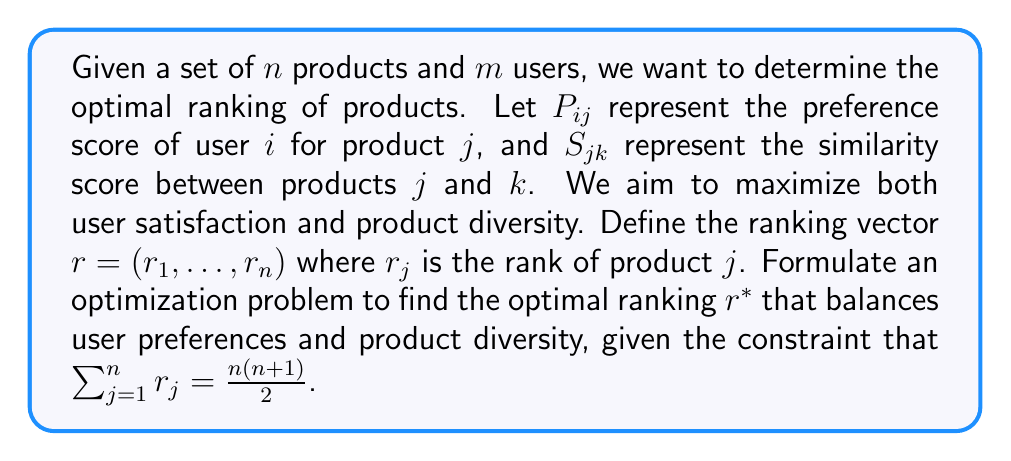Can you answer this question? To solve this inverse problem, we need to formulate an optimization problem that balances user preferences and product diversity. Let's break it down step-by-step:

1. Define the objective function:
   We want to maximize two components: user satisfaction and product diversity.

   a) User satisfaction: $\sum_{i=1}^m \sum_{j=1}^n P_{ij} \cdot (n+1-r_j)$
      This term rewards higher ranks (lower $r_j$ values) for products with higher preference scores.

   b) Product diversity: $-\lambda \sum_{j=1}^n \sum_{k=1}^n S_{jk} \cdot |r_j - r_k|$
      This term penalizes similar products having close ranks. $\lambda$ is a weighting factor.

2. Combine the components:
   $$\max_{r} \left( \sum_{i=1}^m \sum_{j=1}^n P_{ij} \cdot (n+1-r_j) - \lambda \sum_{j=1}^n \sum_{k=1}^n S_{jk} \cdot |r_j - r_k| \right)$$

3. Add the constraint:
   $$\text{subject to } \sum_{j=1}^n r_j = \frac{n(n+1)}{2}$$

4. Integer constraint:
   $$r_j \in \{1, 2, \ldots, n\} \text{ for all } j$$

5. Formulate the final optimization problem:
   $$\begin{aligned}
   \max_{r} & \left( \sum_{i=1}^m \sum_{j=1}^n P_{ij} \cdot (n+1-r_j) - \lambda \sum_{j=1}^n \sum_{k=1}^n S_{jk} \cdot |r_j - r_k| \right) \\
   \text{subject to } & \sum_{j=1}^n r_j = \frac{n(n+1)}{2} \\
   & r_j \in \{1, 2, \ldots, n\} \text{ for all } j
   \end{aligned}$$

This formulation creates an integer programming problem that balances user preferences and product diversity while ensuring a valid ranking.
Answer: $$\begin{aligned}
\max_{r} & \left( \sum_{i=1}^m \sum_{j=1}^n P_{ij} \cdot (n+1-r_j) - \lambda \sum_{j=1}^n \sum_{k=1}^n S_{jk} \cdot |r_j - r_k| \right) \\
\text{s.t. } & \sum_{j=1}^n r_j = \frac{n(n+1)}{2}, \; r_j \in \{1, 2, \ldots, n\} \; \forall j
\end{aligned}$$ 